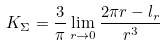<formula> <loc_0><loc_0><loc_500><loc_500>K _ { \Sigma } = \frac { 3 } { \pi } \lim _ { r \rightarrow 0 } \frac { 2 \pi r - l _ { r } } { r ^ { 3 } }</formula> 